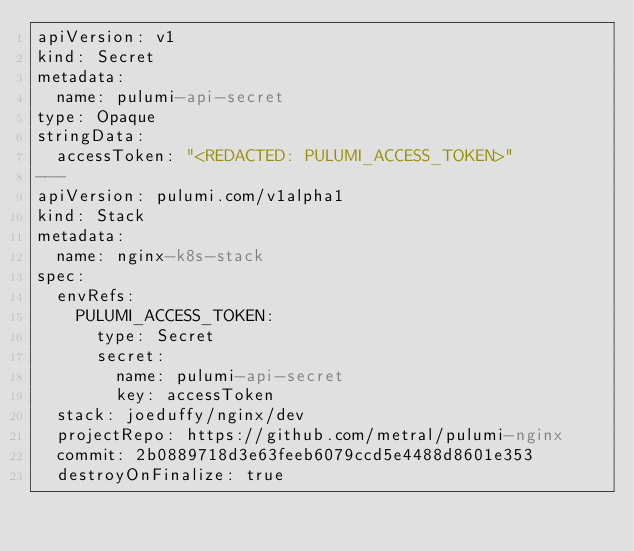Convert code to text. <code><loc_0><loc_0><loc_500><loc_500><_YAML_>apiVersion: v1
kind: Secret
metadata:
  name: pulumi-api-secret
type: Opaque
stringData:
  accessToken: "<REDACTED: PULUMI_ACCESS_TOKEN>"
---
apiVersion: pulumi.com/v1alpha1
kind: Stack
metadata:
  name: nginx-k8s-stack
spec:
  envRefs:
    PULUMI_ACCESS_TOKEN:
      type: Secret
      secret:
        name: pulumi-api-secret
        key: accessToken
  stack: joeduffy/nginx/dev
  projectRepo: https://github.com/metral/pulumi-nginx
  commit: 2b0889718d3e63feeb6079ccd5e4488d8601e353
  destroyOnFinalize: true
</code> 